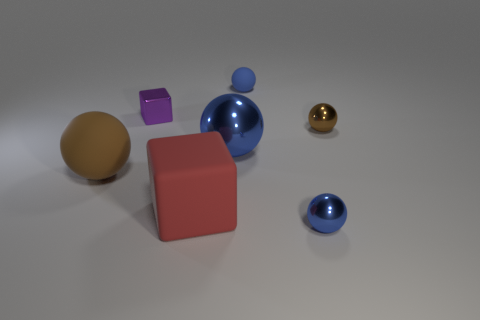Are there the same number of big blue metal spheres that are in front of the big brown thing and red matte objects to the left of the large rubber block?
Your answer should be compact. Yes. There is a tiny metal sphere behind the small object that is in front of the big matte block; how many purple metal objects are on the left side of it?
Offer a very short reply. 1. The small object that is the same color as the tiny matte ball is what shape?
Give a very brief answer. Sphere. Is the color of the large rubber ball the same as the block on the right side of the purple cube?
Provide a succinct answer. No. Is the number of large rubber cubes that are behind the big red matte thing greater than the number of yellow things?
Provide a succinct answer. No. What number of objects are either small objects that are on the left side of the tiny brown sphere or brown things left of the purple cube?
Give a very brief answer. 4. What is the size of the brown thing that is made of the same material as the red thing?
Keep it short and to the point. Large. There is a tiny object that is behind the small purple metal block; does it have the same shape as the big blue thing?
Offer a very short reply. Yes. There is another sphere that is the same color as the large rubber sphere; what size is it?
Provide a succinct answer. Small. What number of red things are either large rubber balls or rubber things?
Provide a short and direct response. 1. 